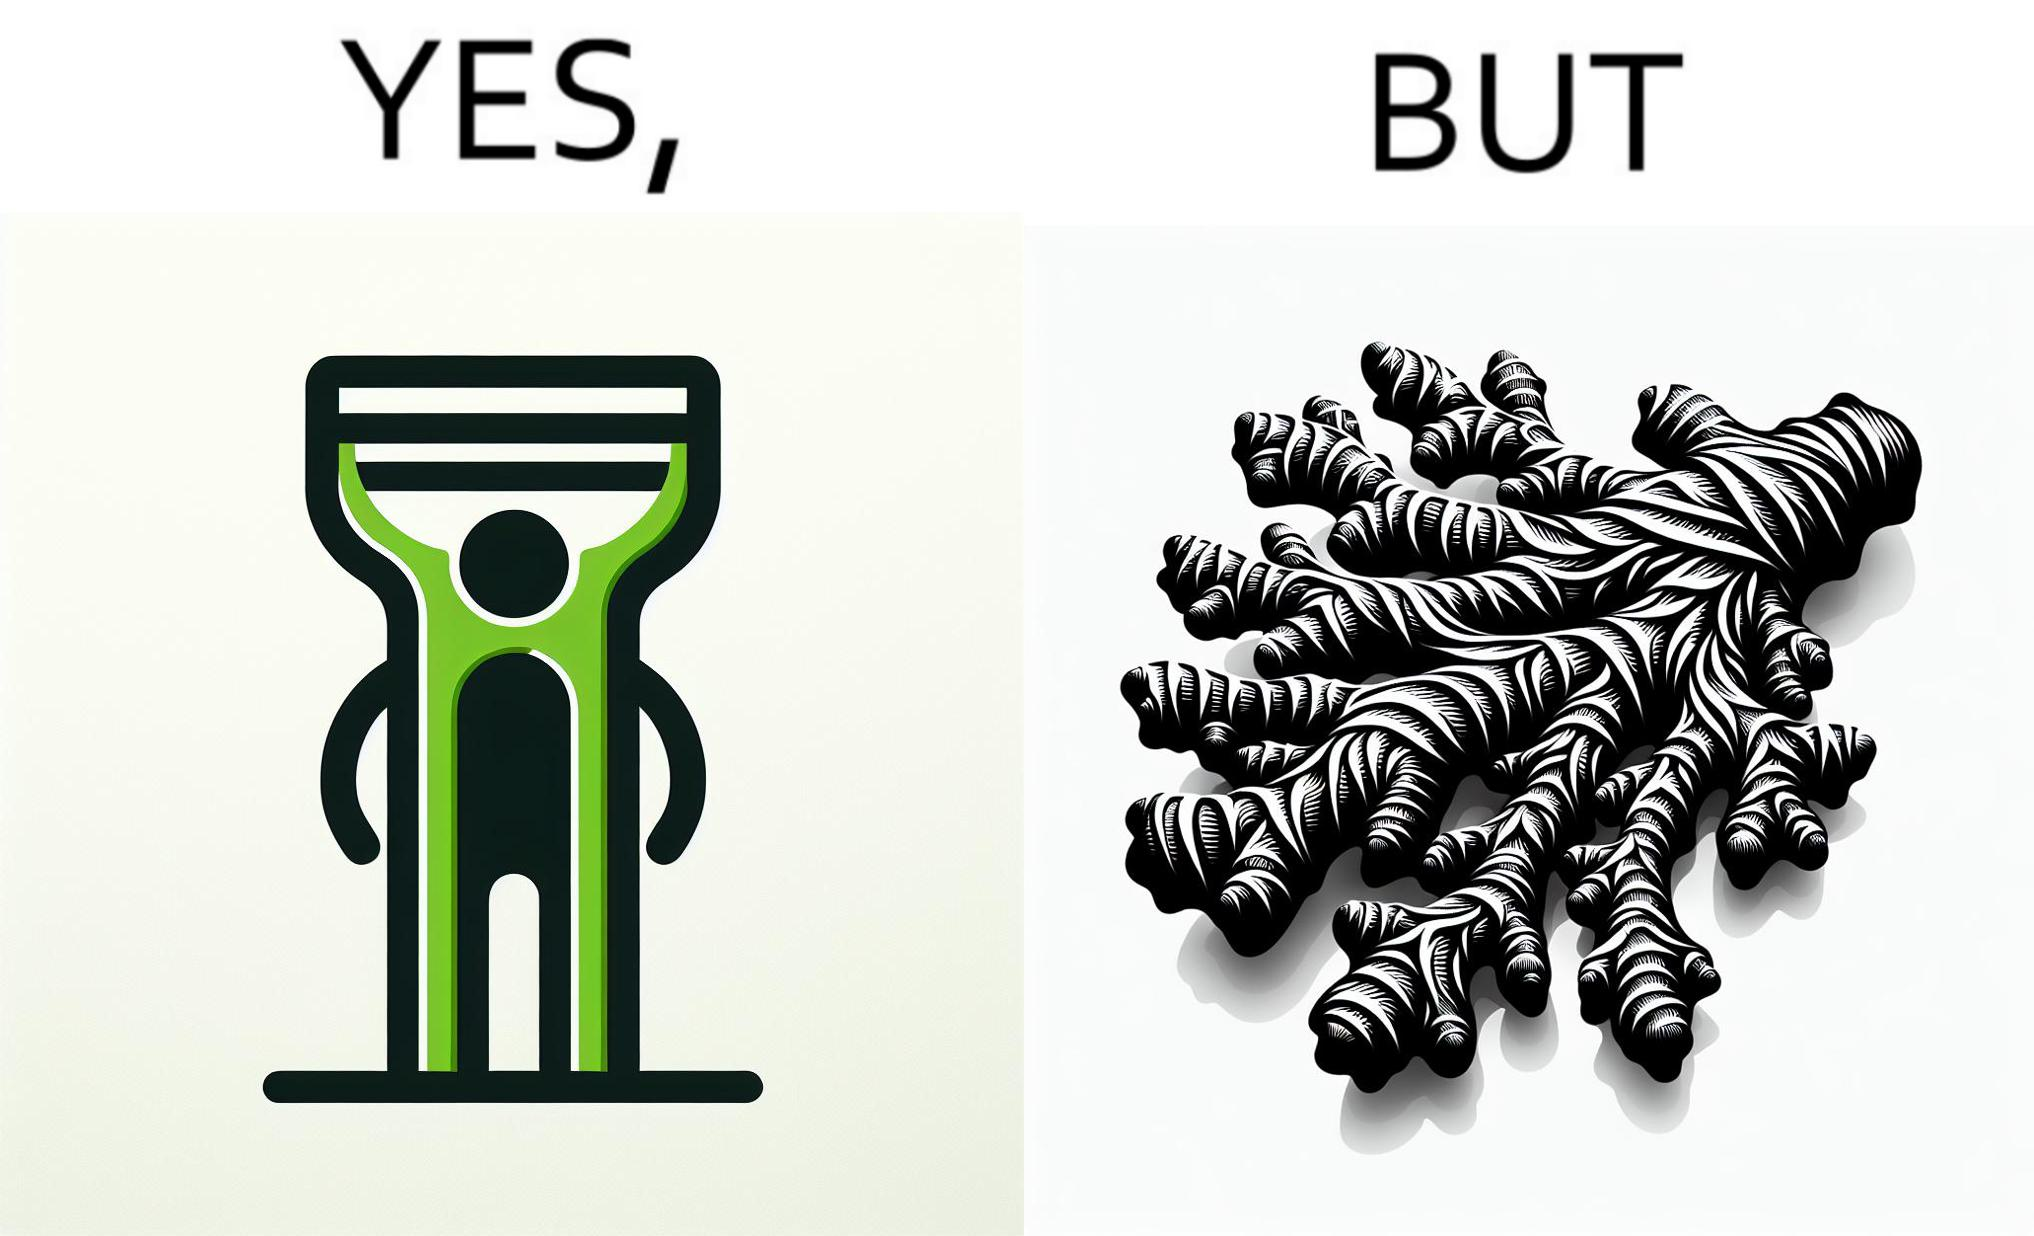Describe what you see in the left and right parts of this image. In the left part of the image: The image shows a green peeler. In the right part of the image: The image shows a ginger root with many branches and a complex shape. 